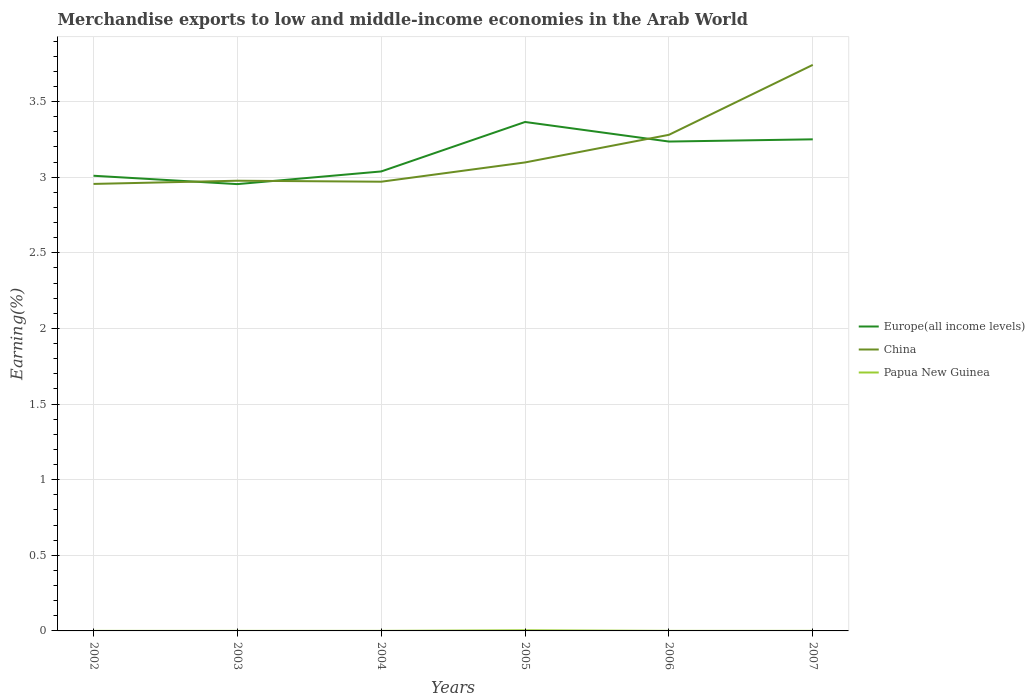Does the line corresponding to China intersect with the line corresponding to Papua New Guinea?
Your answer should be very brief. No. Is the number of lines equal to the number of legend labels?
Your answer should be compact. Yes. Across all years, what is the maximum percentage of amount earned from merchandise exports in China?
Your answer should be very brief. 2.96. In which year was the percentage of amount earned from merchandise exports in Europe(all income levels) maximum?
Make the answer very short. 2003. What is the total percentage of amount earned from merchandise exports in China in the graph?
Make the answer very short. -0.13. What is the difference between the highest and the second highest percentage of amount earned from merchandise exports in Papua New Guinea?
Offer a very short reply. 0. How many lines are there?
Ensure brevity in your answer.  3. Are the values on the major ticks of Y-axis written in scientific E-notation?
Offer a terse response. No. Does the graph contain any zero values?
Give a very brief answer. No. Does the graph contain grids?
Your response must be concise. Yes. Where does the legend appear in the graph?
Your response must be concise. Center right. How many legend labels are there?
Give a very brief answer. 3. What is the title of the graph?
Your response must be concise. Merchandise exports to low and middle-income economies in the Arab World. Does "East Asia (all income levels)" appear as one of the legend labels in the graph?
Provide a short and direct response. No. What is the label or title of the X-axis?
Provide a succinct answer. Years. What is the label or title of the Y-axis?
Offer a terse response. Earning(%). What is the Earning(%) in Europe(all income levels) in 2002?
Keep it short and to the point. 3.01. What is the Earning(%) of China in 2002?
Your response must be concise. 2.96. What is the Earning(%) of Papua New Guinea in 2002?
Ensure brevity in your answer.  0. What is the Earning(%) of Europe(all income levels) in 2003?
Provide a succinct answer. 2.95. What is the Earning(%) of China in 2003?
Offer a very short reply. 2.98. What is the Earning(%) of Papua New Guinea in 2003?
Give a very brief answer. 0. What is the Earning(%) in Europe(all income levels) in 2004?
Provide a succinct answer. 3.04. What is the Earning(%) of China in 2004?
Ensure brevity in your answer.  2.97. What is the Earning(%) in Papua New Guinea in 2004?
Offer a terse response. 0. What is the Earning(%) of Europe(all income levels) in 2005?
Your answer should be very brief. 3.37. What is the Earning(%) in China in 2005?
Provide a short and direct response. 3.1. What is the Earning(%) of Papua New Guinea in 2005?
Your answer should be compact. 0. What is the Earning(%) of Europe(all income levels) in 2006?
Keep it short and to the point. 3.24. What is the Earning(%) in China in 2006?
Make the answer very short. 3.28. What is the Earning(%) in Papua New Guinea in 2006?
Provide a short and direct response. 0. What is the Earning(%) of Europe(all income levels) in 2007?
Offer a very short reply. 3.25. What is the Earning(%) in China in 2007?
Ensure brevity in your answer.  3.74. What is the Earning(%) of Papua New Guinea in 2007?
Your response must be concise. 0. Across all years, what is the maximum Earning(%) of Europe(all income levels)?
Offer a very short reply. 3.37. Across all years, what is the maximum Earning(%) of China?
Your answer should be very brief. 3.74. Across all years, what is the maximum Earning(%) of Papua New Guinea?
Give a very brief answer. 0. Across all years, what is the minimum Earning(%) of Europe(all income levels)?
Offer a very short reply. 2.95. Across all years, what is the minimum Earning(%) in China?
Your answer should be compact. 2.96. Across all years, what is the minimum Earning(%) of Papua New Guinea?
Your answer should be compact. 0. What is the total Earning(%) of Europe(all income levels) in the graph?
Ensure brevity in your answer.  18.85. What is the total Earning(%) in China in the graph?
Ensure brevity in your answer.  19.02. What is the total Earning(%) of Papua New Guinea in the graph?
Your answer should be compact. 0.01. What is the difference between the Earning(%) of Europe(all income levels) in 2002 and that in 2003?
Ensure brevity in your answer.  0.06. What is the difference between the Earning(%) in China in 2002 and that in 2003?
Provide a short and direct response. -0.02. What is the difference between the Earning(%) in Papua New Guinea in 2002 and that in 2003?
Make the answer very short. 0. What is the difference between the Earning(%) of Europe(all income levels) in 2002 and that in 2004?
Give a very brief answer. -0.03. What is the difference between the Earning(%) of China in 2002 and that in 2004?
Your answer should be compact. -0.01. What is the difference between the Earning(%) of Papua New Guinea in 2002 and that in 2004?
Your answer should be compact. -0. What is the difference between the Earning(%) in Europe(all income levels) in 2002 and that in 2005?
Provide a succinct answer. -0.36. What is the difference between the Earning(%) in China in 2002 and that in 2005?
Ensure brevity in your answer.  -0.14. What is the difference between the Earning(%) of Papua New Guinea in 2002 and that in 2005?
Give a very brief answer. -0. What is the difference between the Earning(%) of Europe(all income levels) in 2002 and that in 2006?
Provide a short and direct response. -0.23. What is the difference between the Earning(%) of China in 2002 and that in 2006?
Offer a very short reply. -0.32. What is the difference between the Earning(%) of Europe(all income levels) in 2002 and that in 2007?
Provide a succinct answer. -0.24. What is the difference between the Earning(%) of China in 2002 and that in 2007?
Provide a short and direct response. -0.79. What is the difference between the Earning(%) in Papua New Guinea in 2002 and that in 2007?
Offer a very short reply. -0. What is the difference between the Earning(%) of Europe(all income levels) in 2003 and that in 2004?
Keep it short and to the point. -0.08. What is the difference between the Earning(%) of China in 2003 and that in 2004?
Offer a terse response. 0.01. What is the difference between the Earning(%) of Papua New Guinea in 2003 and that in 2004?
Your answer should be very brief. -0. What is the difference between the Earning(%) of Europe(all income levels) in 2003 and that in 2005?
Keep it short and to the point. -0.41. What is the difference between the Earning(%) in China in 2003 and that in 2005?
Ensure brevity in your answer.  -0.12. What is the difference between the Earning(%) of Papua New Guinea in 2003 and that in 2005?
Make the answer very short. -0. What is the difference between the Earning(%) in Europe(all income levels) in 2003 and that in 2006?
Your answer should be very brief. -0.28. What is the difference between the Earning(%) in China in 2003 and that in 2006?
Make the answer very short. -0.3. What is the difference between the Earning(%) in Papua New Guinea in 2003 and that in 2006?
Keep it short and to the point. -0. What is the difference between the Earning(%) of Europe(all income levels) in 2003 and that in 2007?
Your response must be concise. -0.3. What is the difference between the Earning(%) of China in 2003 and that in 2007?
Provide a succinct answer. -0.77. What is the difference between the Earning(%) of Papua New Guinea in 2003 and that in 2007?
Provide a short and direct response. -0. What is the difference between the Earning(%) in Europe(all income levels) in 2004 and that in 2005?
Make the answer very short. -0.33. What is the difference between the Earning(%) of China in 2004 and that in 2005?
Offer a very short reply. -0.13. What is the difference between the Earning(%) of Papua New Guinea in 2004 and that in 2005?
Your response must be concise. -0. What is the difference between the Earning(%) of Europe(all income levels) in 2004 and that in 2006?
Your answer should be very brief. -0.2. What is the difference between the Earning(%) in China in 2004 and that in 2006?
Your response must be concise. -0.31. What is the difference between the Earning(%) of Papua New Guinea in 2004 and that in 2006?
Your answer should be compact. 0. What is the difference between the Earning(%) of Europe(all income levels) in 2004 and that in 2007?
Give a very brief answer. -0.21. What is the difference between the Earning(%) in China in 2004 and that in 2007?
Provide a short and direct response. -0.77. What is the difference between the Earning(%) in Europe(all income levels) in 2005 and that in 2006?
Give a very brief answer. 0.13. What is the difference between the Earning(%) of China in 2005 and that in 2006?
Offer a terse response. -0.18. What is the difference between the Earning(%) in Papua New Guinea in 2005 and that in 2006?
Your response must be concise. 0. What is the difference between the Earning(%) in Europe(all income levels) in 2005 and that in 2007?
Your response must be concise. 0.11. What is the difference between the Earning(%) of China in 2005 and that in 2007?
Your answer should be compact. -0.65. What is the difference between the Earning(%) of Papua New Guinea in 2005 and that in 2007?
Give a very brief answer. 0. What is the difference between the Earning(%) in Europe(all income levels) in 2006 and that in 2007?
Your response must be concise. -0.01. What is the difference between the Earning(%) in China in 2006 and that in 2007?
Ensure brevity in your answer.  -0.46. What is the difference between the Earning(%) in Papua New Guinea in 2006 and that in 2007?
Give a very brief answer. -0. What is the difference between the Earning(%) of Europe(all income levels) in 2002 and the Earning(%) of China in 2003?
Make the answer very short. 0.03. What is the difference between the Earning(%) of Europe(all income levels) in 2002 and the Earning(%) of Papua New Guinea in 2003?
Provide a short and direct response. 3.01. What is the difference between the Earning(%) of China in 2002 and the Earning(%) of Papua New Guinea in 2003?
Provide a succinct answer. 2.96. What is the difference between the Earning(%) of Europe(all income levels) in 2002 and the Earning(%) of China in 2004?
Provide a succinct answer. 0.04. What is the difference between the Earning(%) in Europe(all income levels) in 2002 and the Earning(%) in Papua New Guinea in 2004?
Offer a terse response. 3.01. What is the difference between the Earning(%) in China in 2002 and the Earning(%) in Papua New Guinea in 2004?
Your answer should be compact. 2.96. What is the difference between the Earning(%) of Europe(all income levels) in 2002 and the Earning(%) of China in 2005?
Provide a short and direct response. -0.09. What is the difference between the Earning(%) in Europe(all income levels) in 2002 and the Earning(%) in Papua New Guinea in 2005?
Your answer should be very brief. 3.01. What is the difference between the Earning(%) in China in 2002 and the Earning(%) in Papua New Guinea in 2005?
Your answer should be compact. 2.95. What is the difference between the Earning(%) in Europe(all income levels) in 2002 and the Earning(%) in China in 2006?
Make the answer very short. -0.27. What is the difference between the Earning(%) in Europe(all income levels) in 2002 and the Earning(%) in Papua New Guinea in 2006?
Offer a very short reply. 3.01. What is the difference between the Earning(%) in China in 2002 and the Earning(%) in Papua New Guinea in 2006?
Ensure brevity in your answer.  2.96. What is the difference between the Earning(%) of Europe(all income levels) in 2002 and the Earning(%) of China in 2007?
Offer a terse response. -0.73. What is the difference between the Earning(%) in Europe(all income levels) in 2002 and the Earning(%) in Papua New Guinea in 2007?
Offer a terse response. 3.01. What is the difference between the Earning(%) of China in 2002 and the Earning(%) of Papua New Guinea in 2007?
Provide a short and direct response. 2.96. What is the difference between the Earning(%) in Europe(all income levels) in 2003 and the Earning(%) in China in 2004?
Make the answer very short. -0.02. What is the difference between the Earning(%) in Europe(all income levels) in 2003 and the Earning(%) in Papua New Guinea in 2004?
Your answer should be compact. 2.95. What is the difference between the Earning(%) in China in 2003 and the Earning(%) in Papua New Guinea in 2004?
Give a very brief answer. 2.98. What is the difference between the Earning(%) of Europe(all income levels) in 2003 and the Earning(%) of China in 2005?
Keep it short and to the point. -0.14. What is the difference between the Earning(%) in Europe(all income levels) in 2003 and the Earning(%) in Papua New Guinea in 2005?
Your answer should be compact. 2.95. What is the difference between the Earning(%) in China in 2003 and the Earning(%) in Papua New Guinea in 2005?
Give a very brief answer. 2.97. What is the difference between the Earning(%) in Europe(all income levels) in 2003 and the Earning(%) in China in 2006?
Ensure brevity in your answer.  -0.33. What is the difference between the Earning(%) in Europe(all income levels) in 2003 and the Earning(%) in Papua New Guinea in 2006?
Ensure brevity in your answer.  2.95. What is the difference between the Earning(%) of China in 2003 and the Earning(%) of Papua New Guinea in 2006?
Keep it short and to the point. 2.98. What is the difference between the Earning(%) in Europe(all income levels) in 2003 and the Earning(%) in China in 2007?
Provide a succinct answer. -0.79. What is the difference between the Earning(%) of Europe(all income levels) in 2003 and the Earning(%) of Papua New Guinea in 2007?
Keep it short and to the point. 2.95. What is the difference between the Earning(%) in China in 2003 and the Earning(%) in Papua New Guinea in 2007?
Give a very brief answer. 2.98. What is the difference between the Earning(%) of Europe(all income levels) in 2004 and the Earning(%) of China in 2005?
Provide a succinct answer. -0.06. What is the difference between the Earning(%) in Europe(all income levels) in 2004 and the Earning(%) in Papua New Guinea in 2005?
Offer a very short reply. 3.03. What is the difference between the Earning(%) of China in 2004 and the Earning(%) of Papua New Guinea in 2005?
Give a very brief answer. 2.97. What is the difference between the Earning(%) in Europe(all income levels) in 2004 and the Earning(%) in China in 2006?
Provide a short and direct response. -0.24. What is the difference between the Earning(%) of Europe(all income levels) in 2004 and the Earning(%) of Papua New Guinea in 2006?
Ensure brevity in your answer.  3.04. What is the difference between the Earning(%) of China in 2004 and the Earning(%) of Papua New Guinea in 2006?
Offer a terse response. 2.97. What is the difference between the Earning(%) in Europe(all income levels) in 2004 and the Earning(%) in China in 2007?
Provide a short and direct response. -0.7. What is the difference between the Earning(%) in Europe(all income levels) in 2004 and the Earning(%) in Papua New Guinea in 2007?
Give a very brief answer. 3.04. What is the difference between the Earning(%) of China in 2004 and the Earning(%) of Papua New Guinea in 2007?
Your answer should be compact. 2.97. What is the difference between the Earning(%) in Europe(all income levels) in 2005 and the Earning(%) in China in 2006?
Ensure brevity in your answer.  0.08. What is the difference between the Earning(%) in Europe(all income levels) in 2005 and the Earning(%) in Papua New Guinea in 2006?
Your response must be concise. 3.36. What is the difference between the Earning(%) in China in 2005 and the Earning(%) in Papua New Guinea in 2006?
Your response must be concise. 3.1. What is the difference between the Earning(%) of Europe(all income levels) in 2005 and the Earning(%) of China in 2007?
Your answer should be very brief. -0.38. What is the difference between the Earning(%) of Europe(all income levels) in 2005 and the Earning(%) of Papua New Guinea in 2007?
Keep it short and to the point. 3.36. What is the difference between the Earning(%) in China in 2005 and the Earning(%) in Papua New Guinea in 2007?
Ensure brevity in your answer.  3.1. What is the difference between the Earning(%) of Europe(all income levels) in 2006 and the Earning(%) of China in 2007?
Keep it short and to the point. -0.51. What is the difference between the Earning(%) of Europe(all income levels) in 2006 and the Earning(%) of Papua New Guinea in 2007?
Your answer should be very brief. 3.24. What is the difference between the Earning(%) in China in 2006 and the Earning(%) in Papua New Guinea in 2007?
Provide a succinct answer. 3.28. What is the average Earning(%) of Europe(all income levels) per year?
Provide a succinct answer. 3.14. What is the average Earning(%) in China per year?
Give a very brief answer. 3.17. What is the average Earning(%) of Papua New Guinea per year?
Offer a very short reply. 0. In the year 2002, what is the difference between the Earning(%) of Europe(all income levels) and Earning(%) of China?
Your answer should be very brief. 0.05. In the year 2002, what is the difference between the Earning(%) in Europe(all income levels) and Earning(%) in Papua New Guinea?
Your answer should be very brief. 3.01. In the year 2002, what is the difference between the Earning(%) of China and Earning(%) of Papua New Guinea?
Keep it short and to the point. 2.96. In the year 2003, what is the difference between the Earning(%) of Europe(all income levels) and Earning(%) of China?
Offer a terse response. -0.02. In the year 2003, what is the difference between the Earning(%) of Europe(all income levels) and Earning(%) of Papua New Guinea?
Provide a succinct answer. 2.95. In the year 2003, what is the difference between the Earning(%) in China and Earning(%) in Papua New Guinea?
Offer a terse response. 2.98. In the year 2004, what is the difference between the Earning(%) of Europe(all income levels) and Earning(%) of China?
Ensure brevity in your answer.  0.07. In the year 2004, what is the difference between the Earning(%) of Europe(all income levels) and Earning(%) of Papua New Guinea?
Provide a succinct answer. 3.04. In the year 2004, what is the difference between the Earning(%) in China and Earning(%) in Papua New Guinea?
Provide a succinct answer. 2.97. In the year 2005, what is the difference between the Earning(%) of Europe(all income levels) and Earning(%) of China?
Keep it short and to the point. 0.27. In the year 2005, what is the difference between the Earning(%) in Europe(all income levels) and Earning(%) in Papua New Guinea?
Keep it short and to the point. 3.36. In the year 2005, what is the difference between the Earning(%) of China and Earning(%) of Papua New Guinea?
Your response must be concise. 3.09. In the year 2006, what is the difference between the Earning(%) of Europe(all income levels) and Earning(%) of China?
Give a very brief answer. -0.04. In the year 2006, what is the difference between the Earning(%) of Europe(all income levels) and Earning(%) of Papua New Guinea?
Make the answer very short. 3.24. In the year 2006, what is the difference between the Earning(%) of China and Earning(%) of Papua New Guinea?
Offer a very short reply. 3.28. In the year 2007, what is the difference between the Earning(%) in Europe(all income levels) and Earning(%) in China?
Make the answer very short. -0.49. In the year 2007, what is the difference between the Earning(%) in Europe(all income levels) and Earning(%) in Papua New Guinea?
Your answer should be compact. 3.25. In the year 2007, what is the difference between the Earning(%) in China and Earning(%) in Papua New Guinea?
Give a very brief answer. 3.74. What is the ratio of the Earning(%) of Europe(all income levels) in 2002 to that in 2003?
Keep it short and to the point. 1.02. What is the ratio of the Earning(%) of China in 2002 to that in 2003?
Offer a terse response. 0.99. What is the ratio of the Earning(%) in Papua New Guinea in 2002 to that in 2003?
Keep it short and to the point. 1.25. What is the ratio of the Earning(%) of Europe(all income levels) in 2002 to that in 2004?
Give a very brief answer. 0.99. What is the ratio of the Earning(%) in Papua New Guinea in 2002 to that in 2004?
Give a very brief answer. 0.85. What is the ratio of the Earning(%) of Europe(all income levels) in 2002 to that in 2005?
Offer a terse response. 0.89. What is the ratio of the Earning(%) in China in 2002 to that in 2005?
Your answer should be compact. 0.95. What is the ratio of the Earning(%) of Papua New Guinea in 2002 to that in 2005?
Your response must be concise. 0.08. What is the ratio of the Earning(%) in Europe(all income levels) in 2002 to that in 2006?
Your answer should be compact. 0.93. What is the ratio of the Earning(%) of China in 2002 to that in 2006?
Provide a short and direct response. 0.9. What is the ratio of the Earning(%) in Papua New Guinea in 2002 to that in 2006?
Offer a terse response. 0.92. What is the ratio of the Earning(%) of Europe(all income levels) in 2002 to that in 2007?
Provide a succinct answer. 0.93. What is the ratio of the Earning(%) in China in 2002 to that in 2007?
Offer a terse response. 0.79. What is the ratio of the Earning(%) of Papua New Guinea in 2002 to that in 2007?
Provide a succinct answer. 0.8. What is the ratio of the Earning(%) in Europe(all income levels) in 2003 to that in 2004?
Provide a short and direct response. 0.97. What is the ratio of the Earning(%) of Papua New Guinea in 2003 to that in 2004?
Your response must be concise. 0.68. What is the ratio of the Earning(%) in Europe(all income levels) in 2003 to that in 2005?
Ensure brevity in your answer.  0.88. What is the ratio of the Earning(%) in China in 2003 to that in 2005?
Keep it short and to the point. 0.96. What is the ratio of the Earning(%) of Papua New Guinea in 2003 to that in 2005?
Your response must be concise. 0.06. What is the ratio of the Earning(%) in China in 2003 to that in 2006?
Offer a terse response. 0.91. What is the ratio of the Earning(%) of Papua New Guinea in 2003 to that in 2006?
Your answer should be very brief. 0.74. What is the ratio of the Earning(%) of Europe(all income levels) in 2003 to that in 2007?
Your answer should be compact. 0.91. What is the ratio of the Earning(%) in China in 2003 to that in 2007?
Your response must be concise. 0.8. What is the ratio of the Earning(%) of Papua New Guinea in 2003 to that in 2007?
Provide a succinct answer. 0.65. What is the ratio of the Earning(%) of Europe(all income levels) in 2004 to that in 2005?
Your answer should be compact. 0.9. What is the ratio of the Earning(%) in China in 2004 to that in 2005?
Provide a short and direct response. 0.96. What is the ratio of the Earning(%) in Papua New Guinea in 2004 to that in 2005?
Keep it short and to the point. 0.09. What is the ratio of the Earning(%) of Europe(all income levels) in 2004 to that in 2006?
Provide a short and direct response. 0.94. What is the ratio of the Earning(%) of China in 2004 to that in 2006?
Make the answer very short. 0.91. What is the ratio of the Earning(%) in Papua New Guinea in 2004 to that in 2006?
Make the answer very short. 1.08. What is the ratio of the Earning(%) of Europe(all income levels) in 2004 to that in 2007?
Your answer should be very brief. 0.93. What is the ratio of the Earning(%) in China in 2004 to that in 2007?
Keep it short and to the point. 0.79. What is the ratio of the Earning(%) in Papua New Guinea in 2004 to that in 2007?
Your response must be concise. 0.95. What is the ratio of the Earning(%) in China in 2005 to that in 2006?
Your answer should be very brief. 0.94. What is the ratio of the Earning(%) of Papua New Guinea in 2005 to that in 2006?
Your answer should be very brief. 11.5. What is the ratio of the Earning(%) in Europe(all income levels) in 2005 to that in 2007?
Provide a succinct answer. 1.04. What is the ratio of the Earning(%) of China in 2005 to that in 2007?
Give a very brief answer. 0.83. What is the ratio of the Earning(%) in Papua New Guinea in 2005 to that in 2007?
Make the answer very short. 10.05. What is the ratio of the Earning(%) in China in 2006 to that in 2007?
Give a very brief answer. 0.88. What is the ratio of the Earning(%) of Papua New Guinea in 2006 to that in 2007?
Your response must be concise. 0.87. What is the difference between the highest and the second highest Earning(%) in Europe(all income levels)?
Your response must be concise. 0.11. What is the difference between the highest and the second highest Earning(%) in China?
Offer a very short reply. 0.46. What is the difference between the highest and the second highest Earning(%) in Papua New Guinea?
Provide a succinct answer. 0. What is the difference between the highest and the lowest Earning(%) of Europe(all income levels)?
Provide a succinct answer. 0.41. What is the difference between the highest and the lowest Earning(%) in China?
Your answer should be very brief. 0.79. What is the difference between the highest and the lowest Earning(%) of Papua New Guinea?
Keep it short and to the point. 0. 